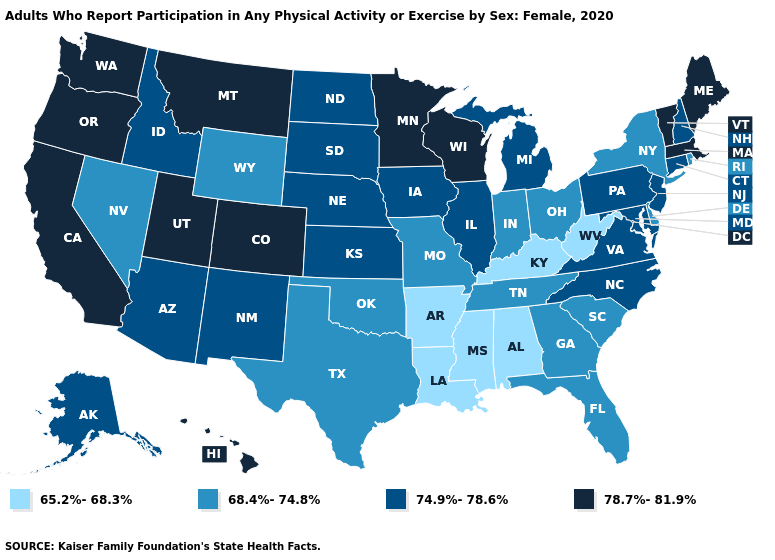Which states hav the highest value in the Northeast?
Be succinct. Maine, Massachusetts, Vermont. Does Idaho have a lower value than Virginia?
Give a very brief answer. No. How many symbols are there in the legend?
Keep it brief. 4. Does the first symbol in the legend represent the smallest category?
Give a very brief answer. Yes. What is the lowest value in the Northeast?
Short answer required. 68.4%-74.8%. Name the states that have a value in the range 65.2%-68.3%?
Give a very brief answer. Alabama, Arkansas, Kentucky, Louisiana, Mississippi, West Virginia. Is the legend a continuous bar?
Quick response, please. No. What is the value of Wisconsin?
Quick response, please. 78.7%-81.9%. Name the states that have a value in the range 78.7%-81.9%?
Quick response, please. California, Colorado, Hawaii, Maine, Massachusetts, Minnesota, Montana, Oregon, Utah, Vermont, Washington, Wisconsin. What is the highest value in the USA?
Quick response, please. 78.7%-81.9%. What is the value of Colorado?
Concise answer only. 78.7%-81.9%. What is the lowest value in states that border Delaware?
Write a very short answer. 74.9%-78.6%. Name the states that have a value in the range 65.2%-68.3%?
Short answer required. Alabama, Arkansas, Kentucky, Louisiana, Mississippi, West Virginia. Among the states that border Kansas , does Colorado have the highest value?
Keep it brief. Yes. Name the states that have a value in the range 74.9%-78.6%?
Answer briefly. Alaska, Arizona, Connecticut, Idaho, Illinois, Iowa, Kansas, Maryland, Michigan, Nebraska, New Hampshire, New Jersey, New Mexico, North Carolina, North Dakota, Pennsylvania, South Dakota, Virginia. 